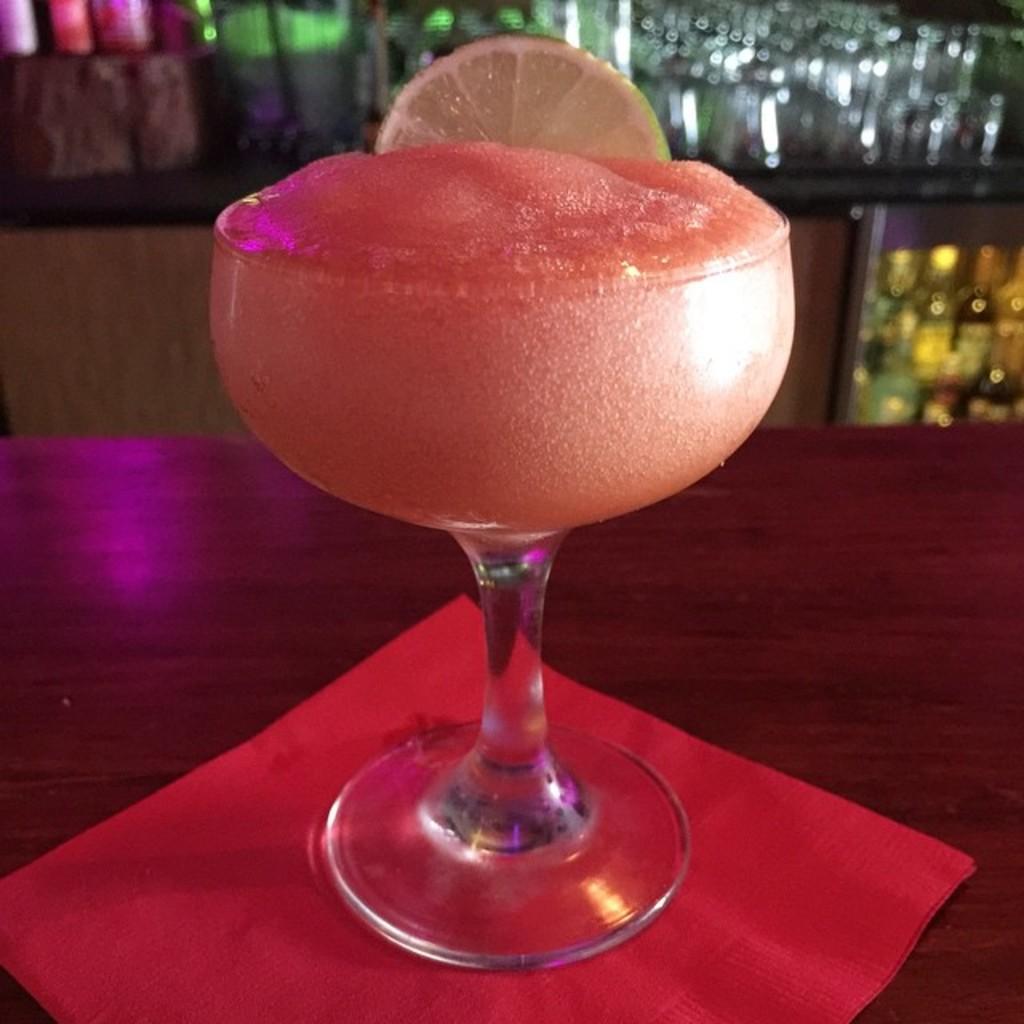In one or two sentences, can you explain what this image depicts? In this image there is a juice and a slice of a lemon in a glass which was placed on the table. In the background of the image there are bottles, glasses in a wooden cupboard. 